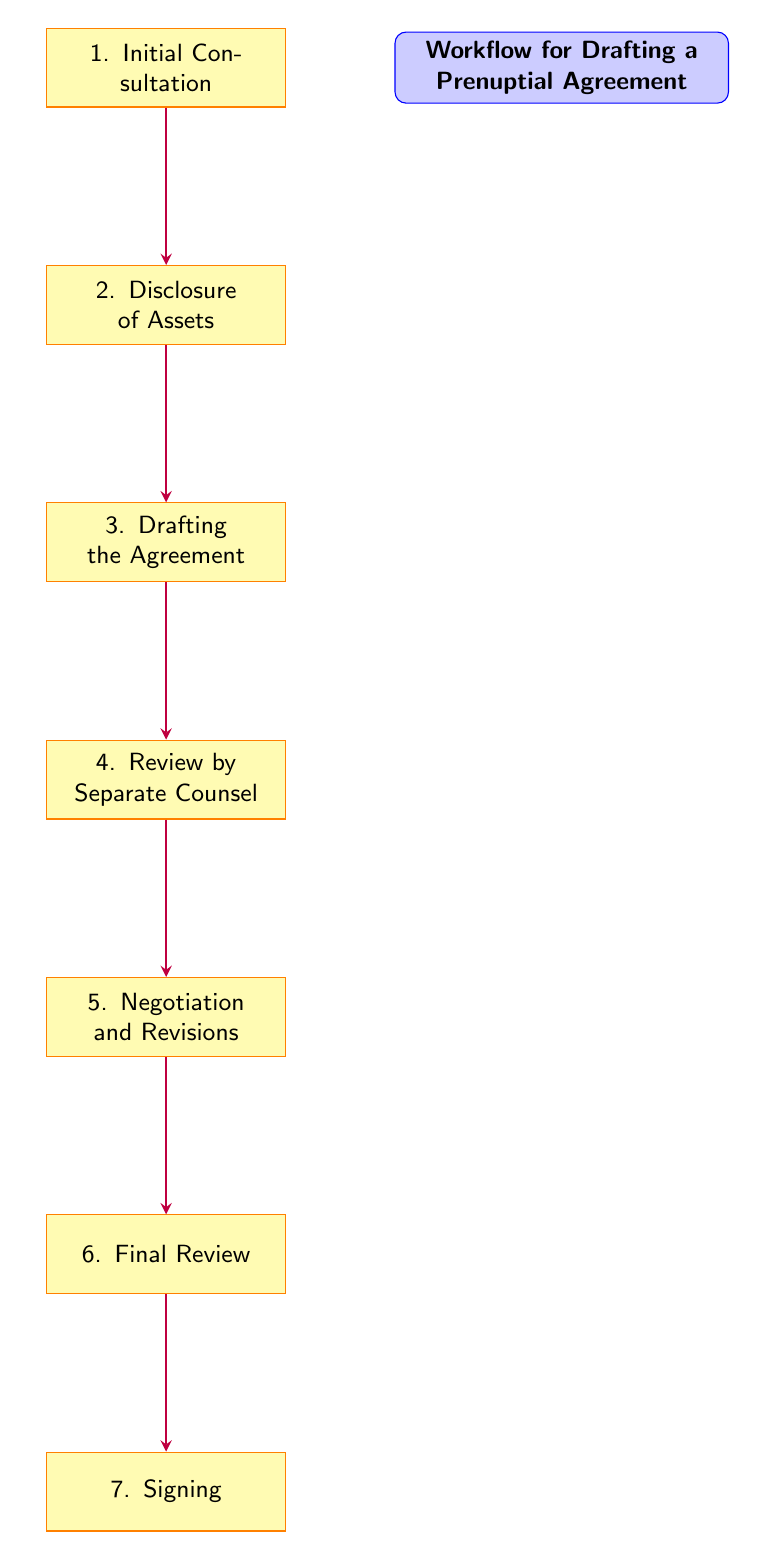What is the first step in the workflow? The first step in the workflow, as indicated by the topmost node, is "Initial Consultation." This node serves as the starting point of the flow chart, establishing the initial meeting to discuss goals and gather information.
Answer: Initial Consultation How many nodes are in the workflow? The flow chart has a total of seven nodes, as there are seven distinct steps outlined in the process of drafting a prenuptial agreement.
Answer: 7 What is the fifth step in the workflow? The fifth step in the workflow is "Negotiation and Revisions," which follows the "Review by Separate Counsel" node and comes before the "Final Review" node.
Answer: Negotiation and Revisions Which step follows the "Disclosure of Assets"? The step that follows "Disclosure of Assets" is "Drafting the Agreement." This can be determined by looking at the arrows connecting the nodes in the flow chart.
Answer: Drafting the Agreement What are the last two steps in the workflow? The last two steps in the workflow are "Final Review" and "Signing." These nodes are positioned at the bottom of the flow chart, following the negotiation process.
Answer: Final Review, Signing Which step is reviewed by separate counsel? The step that is reviewed by separate counsel is "Review by Separate Counsel." It denotes an important stage where each party's legal advisor checks the agreement draft for fairness and understanding.
Answer: Review by Separate Counsel What is the purpose of the "Initial Consultation"? The purpose of the "Initial Consultation" is to meet with each party to discuss their goals and gather preliminary information. This establishes the context for the proceedings and helps define objectives.
Answer: Meeting with each party What action follows "Final Review"? The action that follows "Final Review" is "Signing." After both parties and their counsel confirm that the revisions are satisfactory, they proceed to sign the finalized agreement.
Answer: Signing 